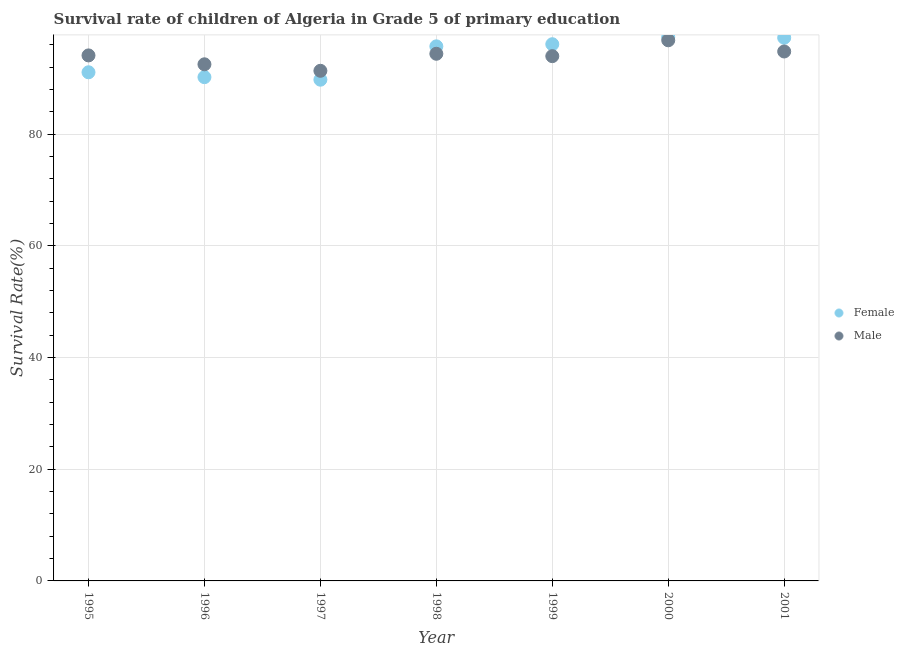Is the number of dotlines equal to the number of legend labels?
Provide a short and direct response. Yes. What is the survival rate of male students in primary education in 1996?
Provide a succinct answer. 92.51. Across all years, what is the maximum survival rate of female students in primary education?
Give a very brief answer. 97.4. Across all years, what is the minimum survival rate of male students in primary education?
Offer a very short reply. 91.35. What is the total survival rate of male students in primary education in the graph?
Give a very brief answer. 657.93. What is the difference between the survival rate of male students in primary education in 1998 and that in 1999?
Offer a very short reply. 0.43. What is the difference between the survival rate of female students in primary education in 1997 and the survival rate of male students in primary education in 1998?
Provide a succinct answer. -4.64. What is the average survival rate of male students in primary education per year?
Offer a very short reply. 93.99. In the year 1995, what is the difference between the survival rate of male students in primary education and survival rate of female students in primary education?
Give a very brief answer. 3.02. What is the ratio of the survival rate of male students in primary education in 1998 to that in 2001?
Ensure brevity in your answer.  1. Is the survival rate of male students in primary education in 1996 less than that in 1998?
Provide a succinct answer. Yes. What is the difference between the highest and the second highest survival rate of male students in primary education?
Offer a terse response. 2. What is the difference between the highest and the lowest survival rate of female students in primary education?
Your answer should be compact. 7.64. Does the survival rate of male students in primary education monotonically increase over the years?
Provide a short and direct response. No. How many years are there in the graph?
Ensure brevity in your answer.  7. What is the difference between two consecutive major ticks on the Y-axis?
Give a very brief answer. 20. Are the values on the major ticks of Y-axis written in scientific E-notation?
Give a very brief answer. No. Does the graph contain grids?
Ensure brevity in your answer.  Yes. Where does the legend appear in the graph?
Your response must be concise. Center right. How many legend labels are there?
Ensure brevity in your answer.  2. What is the title of the graph?
Ensure brevity in your answer.  Survival rate of children of Algeria in Grade 5 of primary education. Does "Forest land" appear as one of the legend labels in the graph?
Offer a very short reply. No. What is the label or title of the X-axis?
Your response must be concise. Year. What is the label or title of the Y-axis?
Provide a succinct answer. Survival Rate(%). What is the Survival Rate(%) in Female in 1995?
Provide a succinct answer. 91.08. What is the Survival Rate(%) in Male in 1995?
Your answer should be very brief. 94.1. What is the Survival Rate(%) of Female in 1996?
Provide a succinct answer. 90.21. What is the Survival Rate(%) of Male in 1996?
Offer a terse response. 92.51. What is the Survival Rate(%) in Female in 1997?
Provide a succinct answer. 89.75. What is the Survival Rate(%) in Male in 1997?
Give a very brief answer. 91.35. What is the Survival Rate(%) in Female in 1998?
Offer a terse response. 95.72. What is the Survival Rate(%) of Male in 1998?
Offer a very short reply. 94.4. What is the Survival Rate(%) of Female in 1999?
Offer a very short reply. 96.11. What is the Survival Rate(%) in Male in 1999?
Offer a very short reply. 93.97. What is the Survival Rate(%) in Female in 2000?
Give a very brief answer. 97.4. What is the Survival Rate(%) in Male in 2000?
Your answer should be very brief. 96.81. What is the Survival Rate(%) of Female in 2001?
Keep it short and to the point. 97.26. What is the Survival Rate(%) in Male in 2001?
Provide a short and direct response. 94.8. Across all years, what is the maximum Survival Rate(%) of Female?
Make the answer very short. 97.4. Across all years, what is the maximum Survival Rate(%) in Male?
Offer a terse response. 96.81. Across all years, what is the minimum Survival Rate(%) in Female?
Offer a terse response. 89.75. Across all years, what is the minimum Survival Rate(%) of Male?
Offer a very short reply. 91.35. What is the total Survival Rate(%) of Female in the graph?
Your answer should be very brief. 657.53. What is the total Survival Rate(%) of Male in the graph?
Your answer should be compact. 657.93. What is the difference between the Survival Rate(%) in Female in 1995 and that in 1996?
Offer a terse response. 0.87. What is the difference between the Survival Rate(%) of Male in 1995 and that in 1996?
Offer a terse response. 1.59. What is the difference between the Survival Rate(%) in Female in 1995 and that in 1997?
Offer a very short reply. 1.33. What is the difference between the Survival Rate(%) in Male in 1995 and that in 1997?
Provide a succinct answer. 2.76. What is the difference between the Survival Rate(%) of Female in 1995 and that in 1998?
Offer a terse response. -4.64. What is the difference between the Survival Rate(%) in Male in 1995 and that in 1998?
Offer a terse response. -0.29. What is the difference between the Survival Rate(%) in Female in 1995 and that in 1999?
Keep it short and to the point. -5.03. What is the difference between the Survival Rate(%) in Male in 1995 and that in 1999?
Give a very brief answer. 0.13. What is the difference between the Survival Rate(%) of Female in 1995 and that in 2000?
Give a very brief answer. -6.32. What is the difference between the Survival Rate(%) in Male in 1995 and that in 2000?
Keep it short and to the point. -2.71. What is the difference between the Survival Rate(%) in Female in 1995 and that in 2001?
Give a very brief answer. -6.18. What is the difference between the Survival Rate(%) in Male in 1995 and that in 2001?
Provide a succinct answer. -0.7. What is the difference between the Survival Rate(%) of Female in 1996 and that in 1997?
Give a very brief answer. 0.46. What is the difference between the Survival Rate(%) of Male in 1996 and that in 1997?
Your answer should be compact. 1.16. What is the difference between the Survival Rate(%) in Female in 1996 and that in 1998?
Your answer should be compact. -5.52. What is the difference between the Survival Rate(%) in Male in 1996 and that in 1998?
Provide a succinct answer. -1.89. What is the difference between the Survival Rate(%) of Female in 1996 and that in 1999?
Give a very brief answer. -5.9. What is the difference between the Survival Rate(%) in Male in 1996 and that in 1999?
Provide a succinct answer. -1.46. What is the difference between the Survival Rate(%) in Female in 1996 and that in 2000?
Provide a short and direct response. -7.19. What is the difference between the Survival Rate(%) of Male in 1996 and that in 2000?
Give a very brief answer. -4.3. What is the difference between the Survival Rate(%) of Female in 1996 and that in 2001?
Your answer should be very brief. -7.05. What is the difference between the Survival Rate(%) of Male in 1996 and that in 2001?
Offer a very short reply. -2.29. What is the difference between the Survival Rate(%) in Female in 1997 and that in 1998?
Provide a succinct answer. -5.97. What is the difference between the Survival Rate(%) of Male in 1997 and that in 1998?
Your answer should be very brief. -3.05. What is the difference between the Survival Rate(%) in Female in 1997 and that in 1999?
Your response must be concise. -6.35. What is the difference between the Survival Rate(%) in Male in 1997 and that in 1999?
Your answer should be compact. -2.62. What is the difference between the Survival Rate(%) in Female in 1997 and that in 2000?
Give a very brief answer. -7.64. What is the difference between the Survival Rate(%) of Male in 1997 and that in 2000?
Ensure brevity in your answer.  -5.46. What is the difference between the Survival Rate(%) of Female in 1997 and that in 2001?
Your answer should be very brief. -7.51. What is the difference between the Survival Rate(%) in Male in 1997 and that in 2001?
Provide a short and direct response. -3.46. What is the difference between the Survival Rate(%) of Female in 1998 and that in 1999?
Provide a succinct answer. -0.38. What is the difference between the Survival Rate(%) in Male in 1998 and that in 1999?
Make the answer very short. 0.43. What is the difference between the Survival Rate(%) in Female in 1998 and that in 2000?
Make the answer very short. -1.67. What is the difference between the Survival Rate(%) of Male in 1998 and that in 2000?
Ensure brevity in your answer.  -2.41. What is the difference between the Survival Rate(%) in Female in 1998 and that in 2001?
Ensure brevity in your answer.  -1.54. What is the difference between the Survival Rate(%) in Male in 1998 and that in 2001?
Your answer should be compact. -0.41. What is the difference between the Survival Rate(%) in Female in 1999 and that in 2000?
Offer a terse response. -1.29. What is the difference between the Survival Rate(%) of Male in 1999 and that in 2000?
Your response must be concise. -2.84. What is the difference between the Survival Rate(%) of Female in 1999 and that in 2001?
Offer a terse response. -1.16. What is the difference between the Survival Rate(%) in Male in 1999 and that in 2001?
Offer a terse response. -0.83. What is the difference between the Survival Rate(%) of Female in 2000 and that in 2001?
Provide a succinct answer. 0.13. What is the difference between the Survival Rate(%) in Male in 2000 and that in 2001?
Your response must be concise. 2. What is the difference between the Survival Rate(%) in Female in 1995 and the Survival Rate(%) in Male in 1996?
Your answer should be very brief. -1.43. What is the difference between the Survival Rate(%) of Female in 1995 and the Survival Rate(%) of Male in 1997?
Provide a succinct answer. -0.27. What is the difference between the Survival Rate(%) of Female in 1995 and the Survival Rate(%) of Male in 1998?
Provide a short and direct response. -3.31. What is the difference between the Survival Rate(%) in Female in 1995 and the Survival Rate(%) in Male in 1999?
Make the answer very short. -2.89. What is the difference between the Survival Rate(%) of Female in 1995 and the Survival Rate(%) of Male in 2000?
Provide a short and direct response. -5.73. What is the difference between the Survival Rate(%) in Female in 1995 and the Survival Rate(%) in Male in 2001?
Offer a terse response. -3.72. What is the difference between the Survival Rate(%) of Female in 1996 and the Survival Rate(%) of Male in 1997?
Keep it short and to the point. -1.14. What is the difference between the Survival Rate(%) in Female in 1996 and the Survival Rate(%) in Male in 1998?
Make the answer very short. -4.19. What is the difference between the Survival Rate(%) in Female in 1996 and the Survival Rate(%) in Male in 1999?
Make the answer very short. -3.76. What is the difference between the Survival Rate(%) in Female in 1996 and the Survival Rate(%) in Male in 2000?
Keep it short and to the point. -6.6. What is the difference between the Survival Rate(%) of Female in 1996 and the Survival Rate(%) of Male in 2001?
Offer a very short reply. -4.6. What is the difference between the Survival Rate(%) of Female in 1997 and the Survival Rate(%) of Male in 1998?
Offer a very short reply. -4.64. What is the difference between the Survival Rate(%) of Female in 1997 and the Survival Rate(%) of Male in 1999?
Your answer should be compact. -4.22. What is the difference between the Survival Rate(%) of Female in 1997 and the Survival Rate(%) of Male in 2000?
Your response must be concise. -7.06. What is the difference between the Survival Rate(%) of Female in 1997 and the Survival Rate(%) of Male in 2001?
Offer a terse response. -5.05. What is the difference between the Survival Rate(%) of Female in 1998 and the Survival Rate(%) of Male in 1999?
Your answer should be compact. 1.76. What is the difference between the Survival Rate(%) of Female in 1998 and the Survival Rate(%) of Male in 2000?
Offer a very short reply. -1.08. What is the difference between the Survival Rate(%) of Female in 1998 and the Survival Rate(%) of Male in 2001?
Your response must be concise. 0.92. What is the difference between the Survival Rate(%) of Female in 1999 and the Survival Rate(%) of Male in 2000?
Provide a short and direct response. -0.7. What is the difference between the Survival Rate(%) in Female in 1999 and the Survival Rate(%) in Male in 2001?
Offer a terse response. 1.3. What is the difference between the Survival Rate(%) in Female in 2000 and the Survival Rate(%) in Male in 2001?
Give a very brief answer. 2.59. What is the average Survival Rate(%) in Female per year?
Provide a succinct answer. 93.93. What is the average Survival Rate(%) in Male per year?
Provide a succinct answer. 93.99. In the year 1995, what is the difference between the Survival Rate(%) of Female and Survival Rate(%) of Male?
Keep it short and to the point. -3.02. In the year 1996, what is the difference between the Survival Rate(%) in Female and Survival Rate(%) in Male?
Make the answer very short. -2.3. In the year 1997, what is the difference between the Survival Rate(%) of Female and Survival Rate(%) of Male?
Offer a terse response. -1.59. In the year 1998, what is the difference between the Survival Rate(%) in Female and Survival Rate(%) in Male?
Ensure brevity in your answer.  1.33. In the year 1999, what is the difference between the Survival Rate(%) in Female and Survival Rate(%) in Male?
Provide a short and direct response. 2.14. In the year 2000, what is the difference between the Survival Rate(%) in Female and Survival Rate(%) in Male?
Keep it short and to the point. 0.59. In the year 2001, what is the difference between the Survival Rate(%) of Female and Survival Rate(%) of Male?
Offer a very short reply. 2.46. What is the ratio of the Survival Rate(%) of Female in 1995 to that in 1996?
Offer a very short reply. 1.01. What is the ratio of the Survival Rate(%) of Male in 1995 to that in 1996?
Make the answer very short. 1.02. What is the ratio of the Survival Rate(%) in Female in 1995 to that in 1997?
Your answer should be very brief. 1.01. What is the ratio of the Survival Rate(%) of Male in 1995 to that in 1997?
Keep it short and to the point. 1.03. What is the ratio of the Survival Rate(%) of Female in 1995 to that in 1998?
Ensure brevity in your answer.  0.95. What is the ratio of the Survival Rate(%) of Female in 1995 to that in 1999?
Provide a short and direct response. 0.95. What is the ratio of the Survival Rate(%) of Male in 1995 to that in 1999?
Give a very brief answer. 1. What is the ratio of the Survival Rate(%) of Female in 1995 to that in 2000?
Offer a terse response. 0.94. What is the ratio of the Survival Rate(%) in Male in 1995 to that in 2000?
Provide a short and direct response. 0.97. What is the ratio of the Survival Rate(%) of Female in 1995 to that in 2001?
Your answer should be very brief. 0.94. What is the ratio of the Survival Rate(%) in Male in 1995 to that in 2001?
Give a very brief answer. 0.99. What is the ratio of the Survival Rate(%) of Female in 1996 to that in 1997?
Your response must be concise. 1.01. What is the ratio of the Survival Rate(%) of Male in 1996 to that in 1997?
Provide a succinct answer. 1.01. What is the ratio of the Survival Rate(%) in Female in 1996 to that in 1998?
Make the answer very short. 0.94. What is the ratio of the Survival Rate(%) in Female in 1996 to that in 1999?
Give a very brief answer. 0.94. What is the ratio of the Survival Rate(%) of Male in 1996 to that in 1999?
Your answer should be compact. 0.98. What is the ratio of the Survival Rate(%) of Female in 1996 to that in 2000?
Keep it short and to the point. 0.93. What is the ratio of the Survival Rate(%) of Male in 1996 to that in 2000?
Your response must be concise. 0.96. What is the ratio of the Survival Rate(%) of Female in 1996 to that in 2001?
Make the answer very short. 0.93. What is the ratio of the Survival Rate(%) in Male in 1996 to that in 2001?
Your answer should be very brief. 0.98. What is the ratio of the Survival Rate(%) in Female in 1997 to that in 1998?
Offer a very short reply. 0.94. What is the ratio of the Survival Rate(%) of Female in 1997 to that in 1999?
Provide a succinct answer. 0.93. What is the ratio of the Survival Rate(%) of Male in 1997 to that in 1999?
Give a very brief answer. 0.97. What is the ratio of the Survival Rate(%) in Female in 1997 to that in 2000?
Make the answer very short. 0.92. What is the ratio of the Survival Rate(%) of Male in 1997 to that in 2000?
Keep it short and to the point. 0.94. What is the ratio of the Survival Rate(%) in Female in 1997 to that in 2001?
Your answer should be compact. 0.92. What is the ratio of the Survival Rate(%) of Male in 1997 to that in 2001?
Make the answer very short. 0.96. What is the ratio of the Survival Rate(%) of Male in 1998 to that in 1999?
Offer a very short reply. 1. What is the ratio of the Survival Rate(%) of Female in 1998 to that in 2000?
Keep it short and to the point. 0.98. What is the ratio of the Survival Rate(%) in Male in 1998 to that in 2000?
Keep it short and to the point. 0.98. What is the ratio of the Survival Rate(%) of Female in 1998 to that in 2001?
Your answer should be compact. 0.98. What is the ratio of the Survival Rate(%) of Female in 1999 to that in 2000?
Make the answer very short. 0.99. What is the ratio of the Survival Rate(%) of Male in 1999 to that in 2000?
Your answer should be compact. 0.97. What is the ratio of the Survival Rate(%) in Male in 1999 to that in 2001?
Give a very brief answer. 0.99. What is the ratio of the Survival Rate(%) in Female in 2000 to that in 2001?
Offer a very short reply. 1. What is the ratio of the Survival Rate(%) of Male in 2000 to that in 2001?
Ensure brevity in your answer.  1.02. What is the difference between the highest and the second highest Survival Rate(%) of Female?
Provide a succinct answer. 0.13. What is the difference between the highest and the second highest Survival Rate(%) in Male?
Provide a succinct answer. 2. What is the difference between the highest and the lowest Survival Rate(%) of Female?
Give a very brief answer. 7.64. What is the difference between the highest and the lowest Survival Rate(%) in Male?
Make the answer very short. 5.46. 